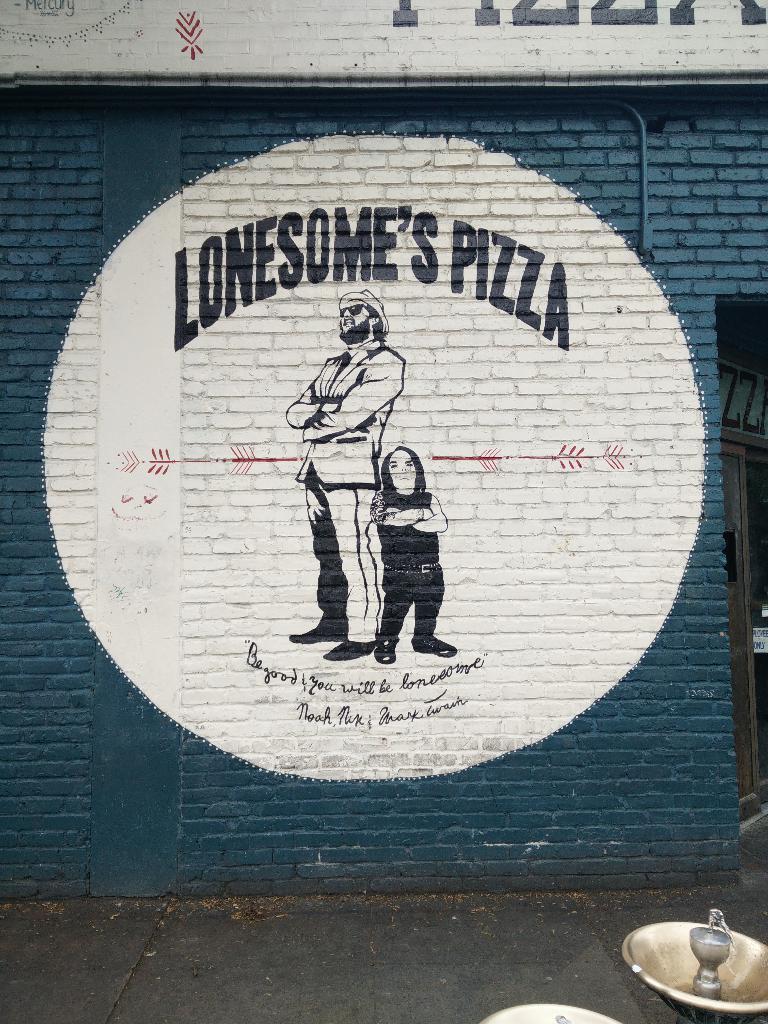Can you describe this image briefly? In this image I see the blue color wall on which there is an art and I see that there are 2 persons over here and I see few words written and I see the path and I see a thing over here. 